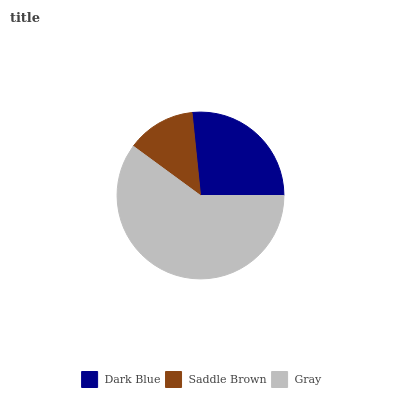Is Saddle Brown the minimum?
Answer yes or no. Yes. Is Gray the maximum?
Answer yes or no. Yes. Is Gray the minimum?
Answer yes or no. No. Is Saddle Brown the maximum?
Answer yes or no. No. Is Gray greater than Saddle Brown?
Answer yes or no. Yes. Is Saddle Brown less than Gray?
Answer yes or no. Yes. Is Saddle Brown greater than Gray?
Answer yes or no. No. Is Gray less than Saddle Brown?
Answer yes or no. No. Is Dark Blue the high median?
Answer yes or no. Yes. Is Dark Blue the low median?
Answer yes or no. Yes. Is Saddle Brown the high median?
Answer yes or no. No. Is Saddle Brown the low median?
Answer yes or no. No. 